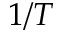Convert formula to latex. <formula><loc_0><loc_0><loc_500><loc_500>1 / T</formula> 